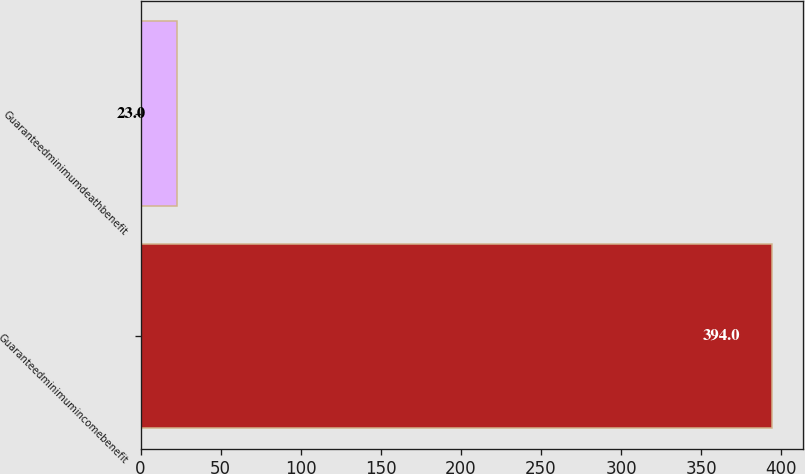Convert chart. <chart><loc_0><loc_0><loc_500><loc_500><bar_chart><fcel>Guaranteedminimumincomebenefit<fcel>Guaranteedminimumdeathbenefit<nl><fcel>394<fcel>23<nl></chart> 